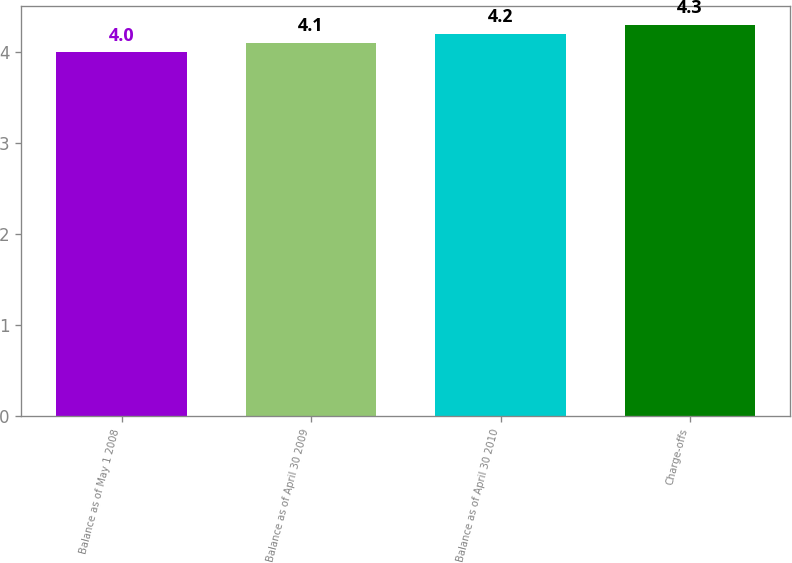Convert chart to OTSL. <chart><loc_0><loc_0><loc_500><loc_500><bar_chart><fcel>Balance as of May 1 2008<fcel>Balance as of April 30 2009<fcel>Balance as of April 30 2010<fcel>Charge-offs<nl><fcel>4<fcel>4.1<fcel>4.2<fcel>4.3<nl></chart> 